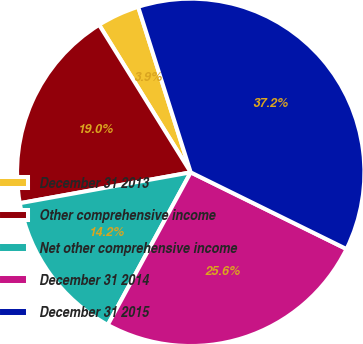Convert chart to OTSL. <chart><loc_0><loc_0><loc_500><loc_500><pie_chart><fcel>December 31 2013<fcel>Other comprehensive income<fcel>Net other comprehensive income<fcel>December 31 2014<fcel>December 31 2015<nl><fcel>3.95%<fcel>19.0%<fcel>14.23%<fcel>25.65%<fcel>37.18%<nl></chart> 